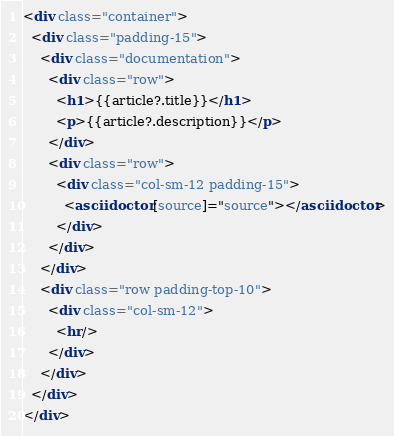<code> <loc_0><loc_0><loc_500><loc_500><_HTML_><div class="container">
  <div class="padding-15">
    <div class="documentation">
      <div class="row">
        <h1>{{article?.title}}</h1>
        <p>{{article?.description}}</p>
      </div>
      <div class="row">
        <div class="col-sm-12 padding-15">
          <asciidoctor [source]="source"></asciidoctor>
        </div>
      </div>
    </div>
    <div class="row padding-top-10">
      <div class="col-sm-12">
        <hr/>
      </div>
    </div>
  </div>
</div>
</code> 